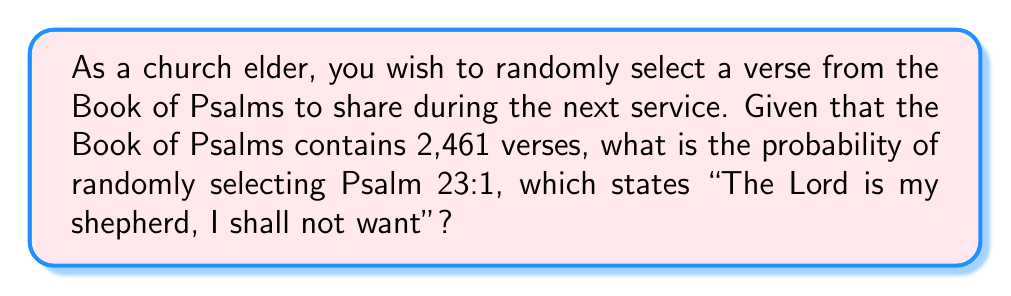Can you solve this math problem? Let's approach this step-by-step:

1) In probability theory, when we have a set of equally likely outcomes and we're selecting one outcome, the probability is calculated as:

   $$ P(\text{event}) = \frac{\text{number of favorable outcomes}}{\text{total number of possible outcomes}} $$

2) In this case:
   - The total number of possible outcomes is the total number of verses in the Book of Psalms: 2,461
   - The number of favorable outcomes is 1 (we're looking for one specific verse)

3) Therefore, the probability of randomly selecting Psalm 23:1 is:

   $$ P(\text{Psalm 23:1}) = \frac{1}{2461} $$

4) This fraction can be left as is, or if we want to express it as a decimal:

   $$ P(\text{Psalm 23:1}) \approx 0.0004063 $$

5) If we want to express it as a percentage:

   $$ P(\text{Psalm 23:1}) \approx 0.0406\% $$

This means that if we were to randomly select a verse from the Book of Psalms, we would have about a 0.0406% chance of selecting Psalm 23:1.
Answer: $\frac{1}{2461}$ or approximately 0.0406% 